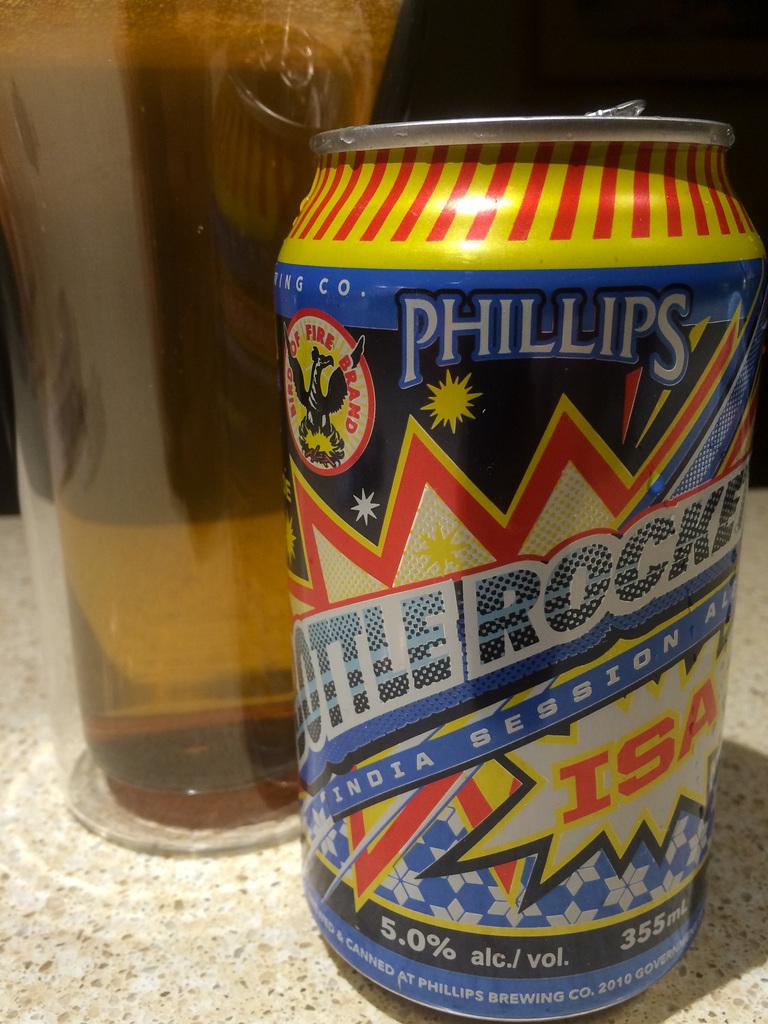<image>
Describe the image concisely. A can of Phillips Bottle Rocket contains 355 mL. 